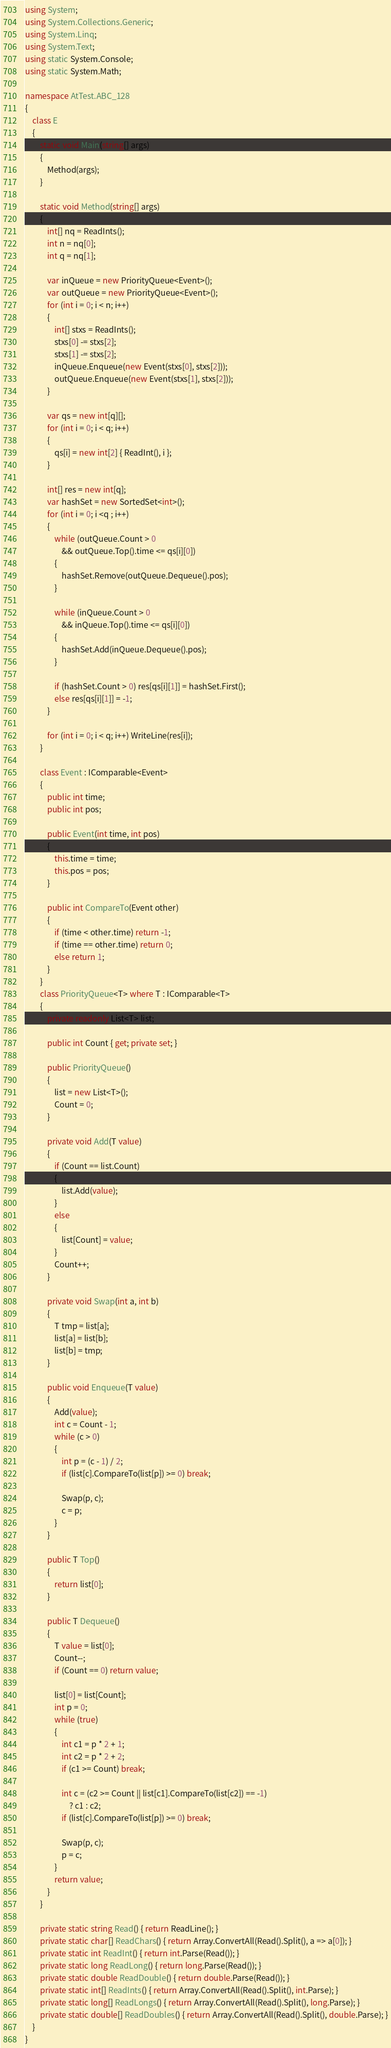Convert code to text. <code><loc_0><loc_0><loc_500><loc_500><_C#_>using System;
using System.Collections.Generic;
using System.Linq;
using System.Text;
using static System.Console;
using static System.Math;

namespace AtTest.ABC_128
{
    class E
    {
        static void Main(string[] args)
        {
            Method(args);
        }

        static void Method(string[] args)
        {
            int[] nq = ReadInts();
            int n = nq[0];
            int q = nq[1];

            var inQueue = new PriorityQueue<Event>();
            var outQueue = new PriorityQueue<Event>();
            for (int i = 0; i < n; i++)
            {
                int[] stxs = ReadInts();
                stxs[0] -= stxs[2];
                stxs[1] -= stxs[2];
                inQueue.Enqueue(new Event(stxs[0], stxs[2]));
                outQueue.Enqueue(new Event(stxs[1], stxs[2]));
            }

            var qs = new int[q][];
            for (int i = 0; i < q; i++)
            {
                qs[i] = new int[2] { ReadInt(), i };
            }
            
            int[] res = new int[q];
            var hashSet = new SortedSet<int>();
            for (int i = 0; i <q ; i++)
            {
                while (outQueue.Count > 0
                    && outQueue.Top().time <= qs[i][0])
                {
                    hashSet.Remove(outQueue.Dequeue().pos);
                }

                while (inQueue.Count > 0
                    && inQueue.Top().time <= qs[i][0])
                {
                    hashSet.Add(inQueue.Dequeue().pos);
                }

                if (hashSet.Count > 0) res[qs[i][1]] = hashSet.First();
                else res[qs[i][1]] = -1;
            }

            for (int i = 0; i < q; i++) WriteLine(res[i]);
        }

        class Event : IComparable<Event>
        {
            public int time;
            public int pos;

            public Event(int time, int pos)
            {
                this.time = time;
                this.pos = pos;
            }

            public int CompareTo(Event other)
            {
                if (time < other.time) return -1;
                if (time == other.time) return 0;
                else return 1;
            }
        }
        class PriorityQueue<T> where T : IComparable<T>
        {
            private readonly List<T> list;

            public int Count { get; private set; }

            public PriorityQueue()
            {
                list = new List<T>();
                Count = 0;
            }

            private void Add(T value)
            {
                if (Count == list.Count)
                {
                    list.Add(value);
                }
                else
                {
                    list[Count] = value;
                }
                Count++;
            }

            private void Swap(int a, int b)
            {
                T tmp = list[a];
                list[a] = list[b];
                list[b] = tmp;
            }

            public void Enqueue(T value)
            {
                Add(value);
                int c = Count - 1;
                while (c > 0)
                {
                    int p = (c - 1) / 2;
                    if (list[c].CompareTo(list[p]) >= 0) break;

                    Swap(p, c);
                    c = p;
                }
            }

            public T Top()
            {
                return list[0];
            }

            public T Dequeue()
            {
                T value = list[0];
                Count--;
                if (Count == 0) return value;

                list[0] = list[Count];
                int p = 0;
                while (true)
                {
                    int c1 = p * 2 + 1;
                    int c2 = p * 2 + 2;
                    if (c1 >= Count) break;

                    int c = (c2 >= Count || list[c1].CompareTo(list[c2]) == -1)
                        ? c1 : c2;
                    if (list[c].CompareTo(list[p]) >= 0) break;

                    Swap(p, c);
                    p = c;
                }
                return value;
            }
        }

        private static string Read() { return ReadLine(); }
        private static char[] ReadChars() { return Array.ConvertAll(Read().Split(), a => a[0]); }
        private static int ReadInt() { return int.Parse(Read()); }
        private static long ReadLong() { return long.Parse(Read()); }
        private static double ReadDouble() { return double.Parse(Read()); }
        private static int[] ReadInts() { return Array.ConvertAll(Read().Split(), int.Parse); }
        private static long[] ReadLongs() { return Array.ConvertAll(Read().Split(), long.Parse); }
        private static double[] ReadDoubles() { return Array.ConvertAll(Read().Split(), double.Parse); }
    }
}
</code> 